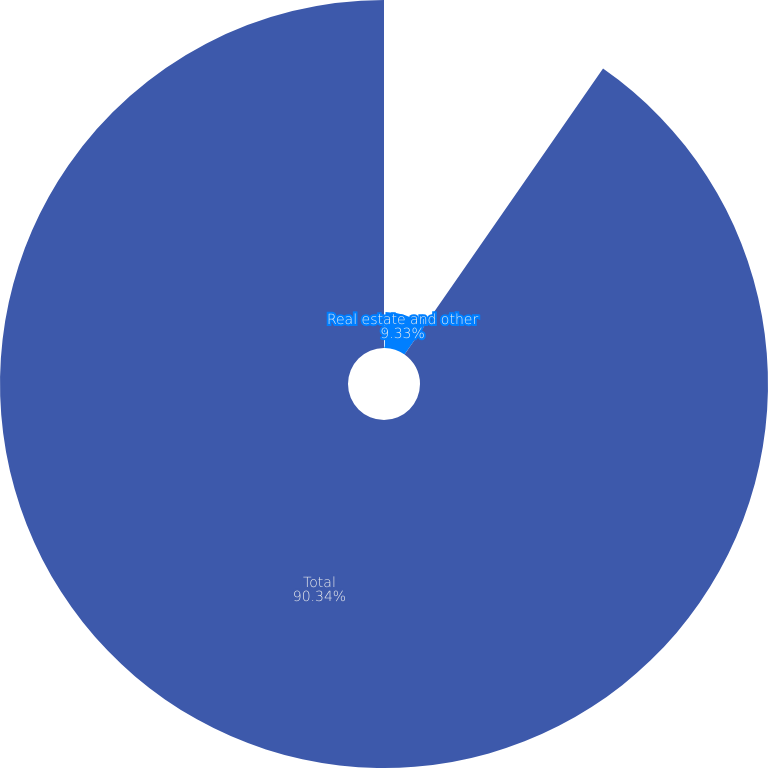Convert chart. <chart><loc_0><loc_0><loc_500><loc_500><pie_chart><fcel>Other (4)<fcel>Real estate and other<fcel>Total<nl><fcel>0.33%<fcel>9.33%<fcel>90.33%<nl></chart> 